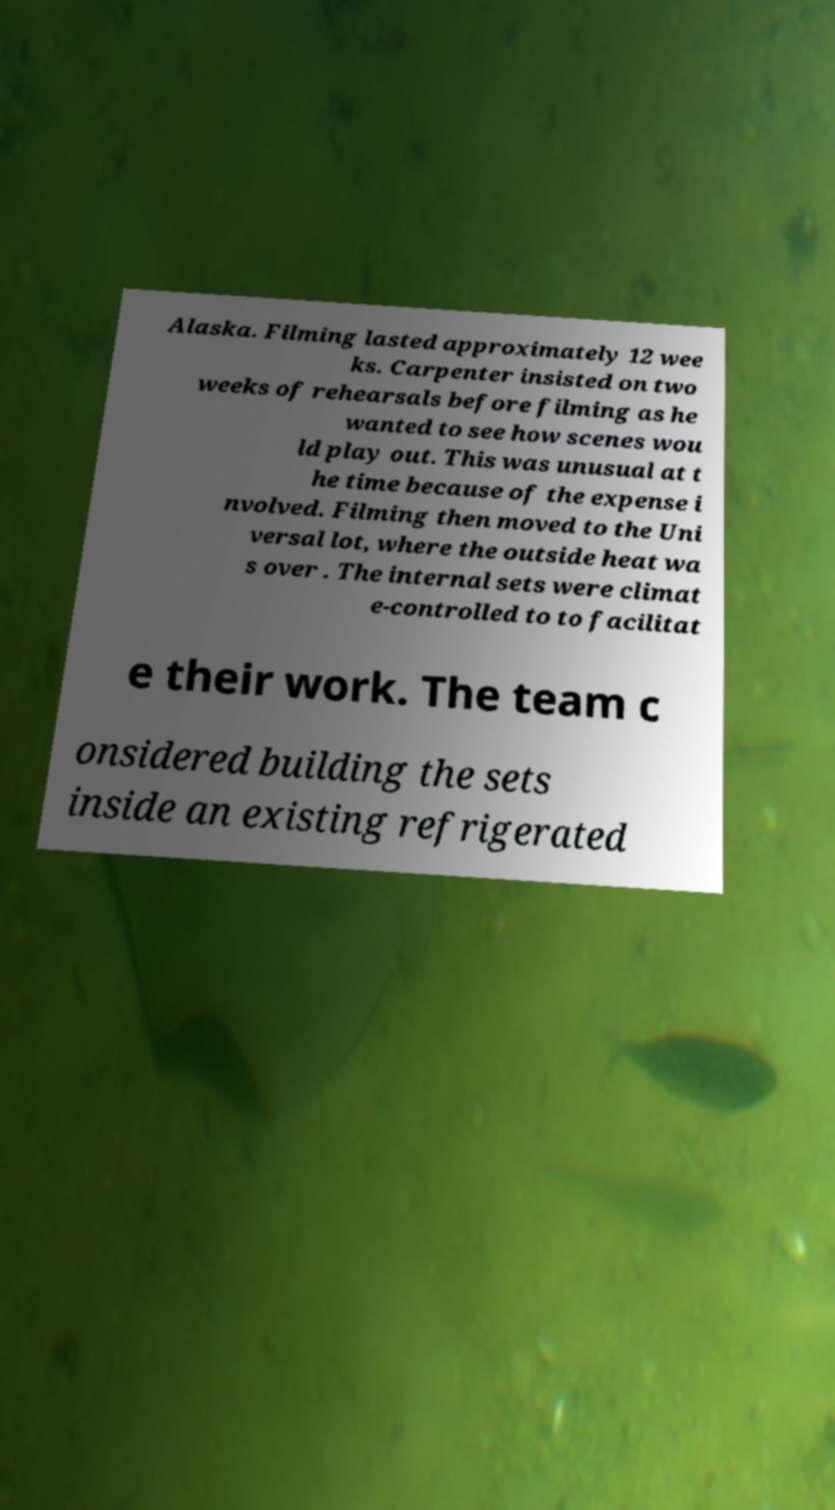Please read and relay the text visible in this image. What does it say? Alaska. Filming lasted approximately 12 wee ks. Carpenter insisted on two weeks of rehearsals before filming as he wanted to see how scenes wou ld play out. This was unusual at t he time because of the expense i nvolved. Filming then moved to the Uni versal lot, where the outside heat wa s over . The internal sets were climat e-controlled to to facilitat e their work. The team c onsidered building the sets inside an existing refrigerated 